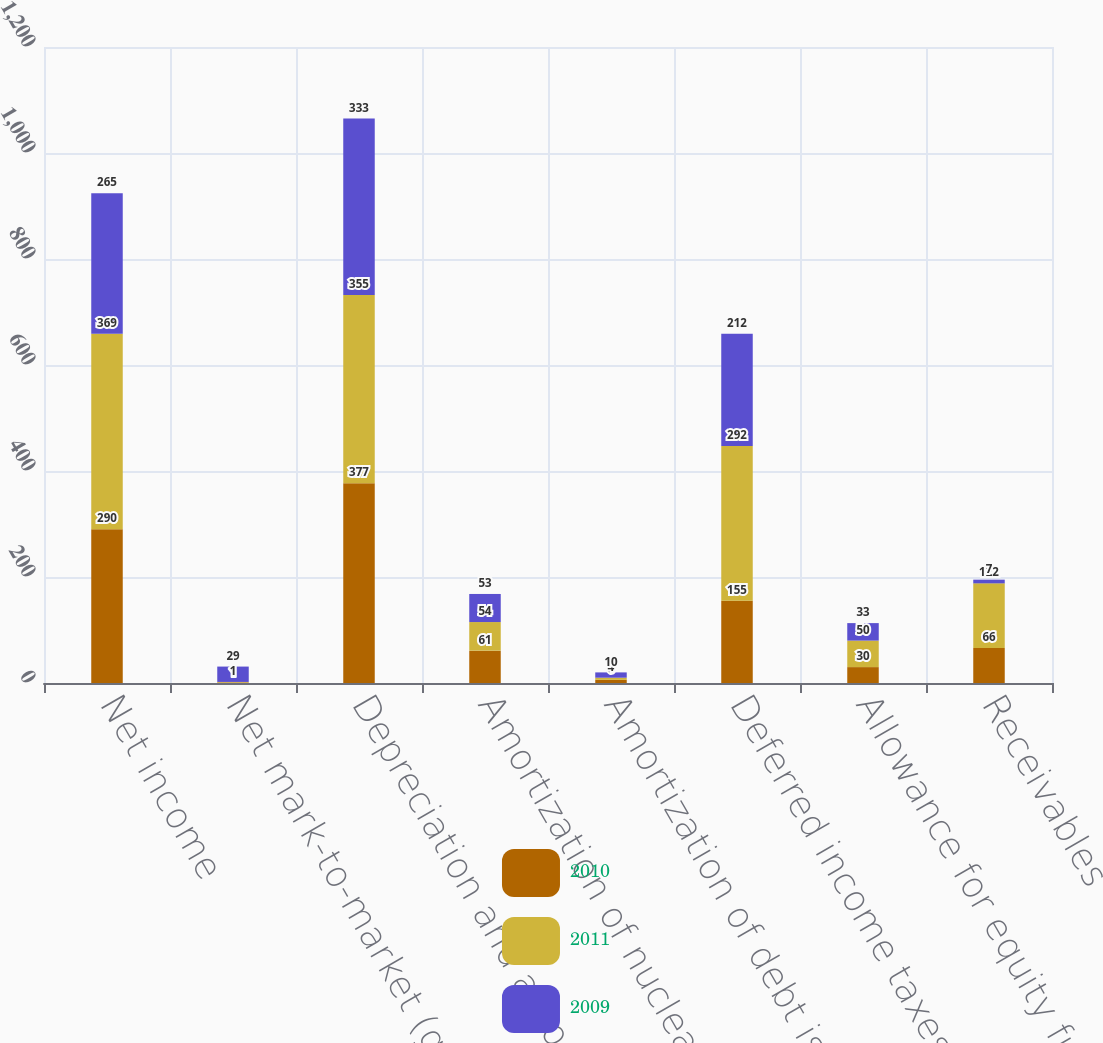Convert chart. <chart><loc_0><loc_0><loc_500><loc_500><stacked_bar_chart><ecel><fcel>Net income<fcel>Net mark-to-market (gain) loss<fcel>Depreciation and amortization<fcel>Amortization of nuclear fuel<fcel>Amortization of debt issuance<fcel>Deferred income taxes and<fcel>Allowance for equity funds<fcel>Receivables<nl><fcel>2010<fcel>290<fcel>1<fcel>377<fcel>61<fcel>6<fcel>155<fcel>30<fcel>66<nl><fcel>2011<fcel>369<fcel>1<fcel>355<fcel>54<fcel>4<fcel>292<fcel>50<fcel>122<nl><fcel>2009<fcel>265<fcel>29<fcel>333<fcel>53<fcel>10<fcel>212<fcel>33<fcel>7<nl></chart> 